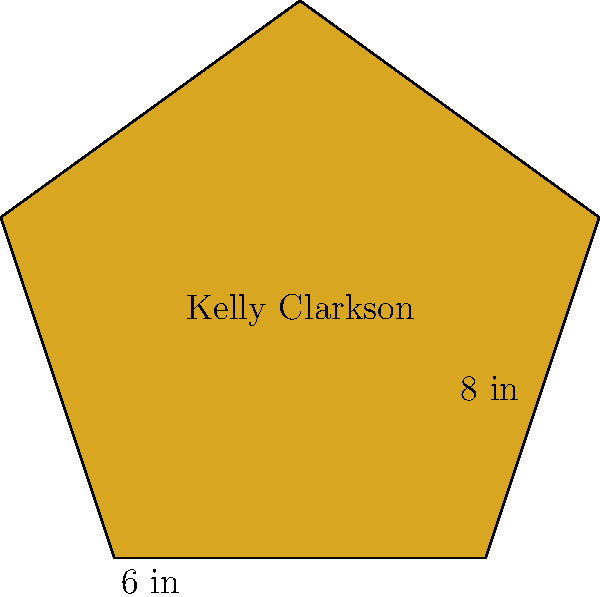As you admire Kelly Clarkson's star on the Hollywood Walk of Fame, you notice it has a unique star shape. If the distance from the center to any point is 8 inches, and the distance between two adjacent points is 6 inches, what is the area of Kelly's star in square inches? (Use $\pi \approx 3.14$ and round your answer to the nearest whole number.) Let's approach this step-by-step:

1) The star can be divided into 10 congruent triangles (5 pointing outward and 5 inward).

2) We need to find the area of one triangle and multiply by 10.

3) Let's focus on one triangle:
   - The base is 6 inches (given)
   - The height needs to be calculated

4) To find the height, we can use the Pythagorean theorem:
   $h^2 + 3^2 = 8^2$
   (half of the base is 3, and the radius is 8)

5) Solving for h:
   $h^2 = 8^2 - 3^2 = 64 - 9 = 55$
   $h = \sqrt{55} \approx 7.42$ inches

6) Now we can calculate the area of one triangle:
   $A_{triangle} = \frac{1}{2} \times base \times height$
   $A_{triangle} = \frac{1}{2} \times 6 \times 7.42 \approx 22.26$ sq inches

7) The total area of the star is:
   $A_{star} = 10 \times A_{triangle} = 10 \times 22.26 \approx 222.6$ sq inches

8) Rounding to the nearest whole number: 223 sq inches
Answer: 223 sq inches 